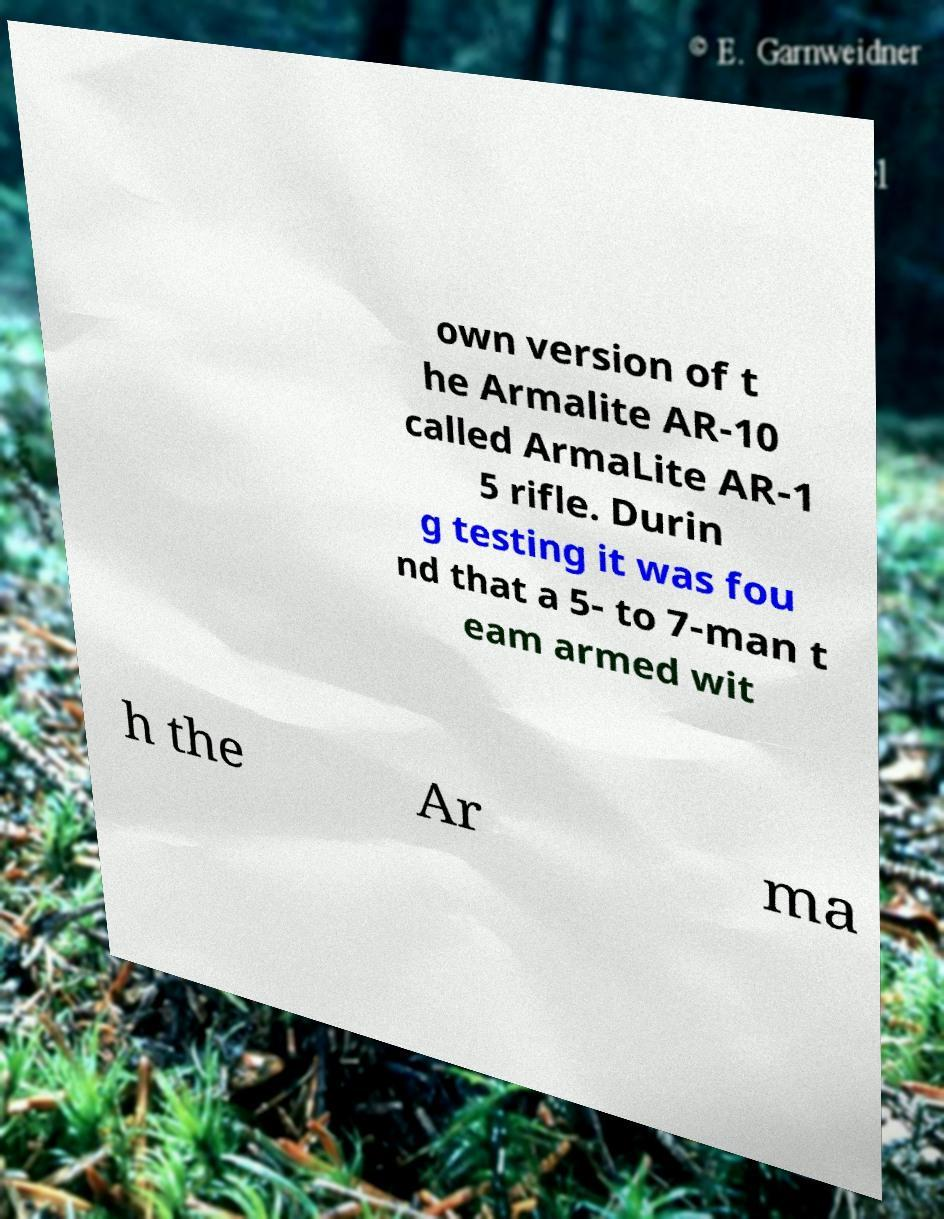There's text embedded in this image that I need extracted. Can you transcribe it verbatim? own version of t he Armalite AR-10 called ArmaLite AR-1 5 rifle. Durin g testing it was fou nd that a 5- to 7-man t eam armed wit h the Ar ma 